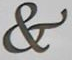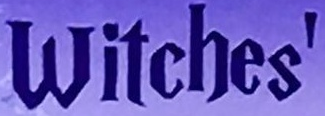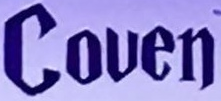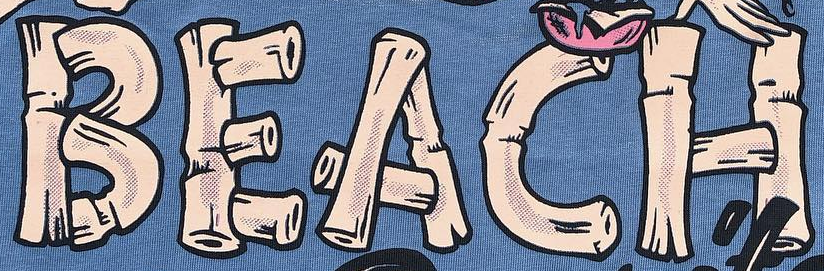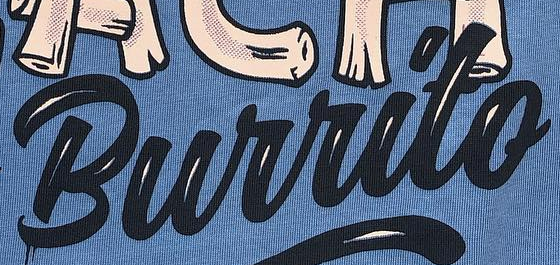What words can you see in these images in sequence, separated by a semicolon? &; Witches'; Couen; BEACH; Burrito 